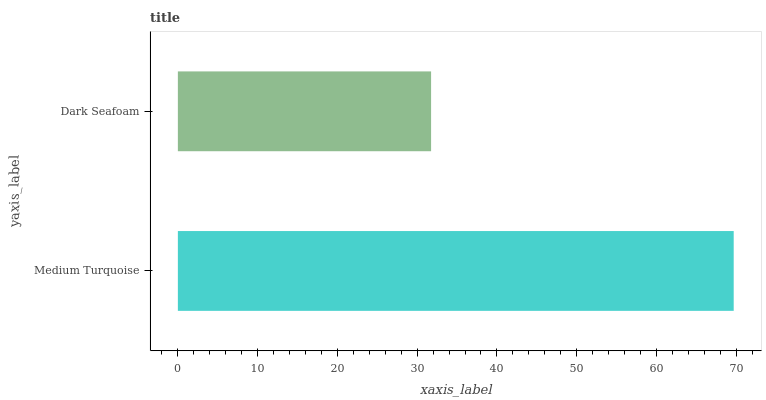Is Dark Seafoam the minimum?
Answer yes or no. Yes. Is Medium Turquoise the maximum?
Answer yes or no. Yes. Is Dark Seafoam the maximum?
Answer yes or no. No. Is Medium Turquoise greater than Dark Seafoam?
Answer yes or no. Yes. Is Dark Seafoam less than Medium Turquoise?
Answer yes or no. Yes. Is Dark Seafoam greater than Medium Turquoise?
Answer yes or no. No. Is Medium Turquoise less than Dark Seafoam?
Answer yes or no. No. Is Medium Turquoise the high median?
Answer yes or no. Yes. Is Dark Seafoam the low median?
Answer yes or no. Yes. Is Dark Seafoam the high median?
Answer yes or no. No. Is Medium Turquoise the low median?
Answer yes or no. No. 